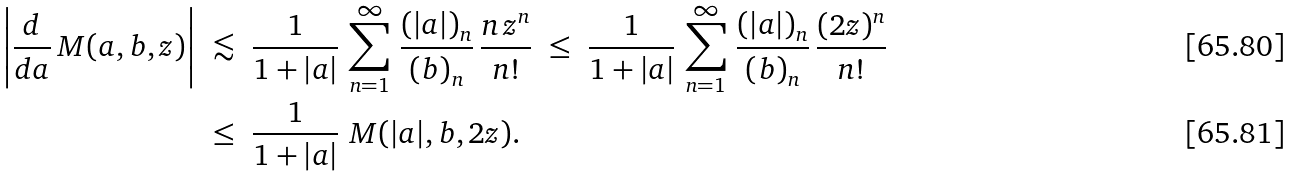Convert formula to latex. <formula><loc_0><loc_0><loc_500><loc_500>\left | \frac { d } { d a } \, M ( a , b , z ) \right | & \ \lesssim \ \frac { 1 } { 1 + | a | } \, \sum _ { n = 1 } ^ { \infty } \, \frac { ( | a | ) _ { n } } { ( b ) _ { n } } \, \frac { n \, z ^ { n } } { n ! } \ \leq \ \frac { 1 } { 1 + | a | } \, \sum _ { n = 1 } ^ { \infty } \, \frac { ( | a | ) _ { n } } { ( b ) _ { n } } \, \frac { ( 2 z ) ^ { n } } { n ! } \\ & \ \leq \ \frac { 1 } { 1 + | a | } \ M ( | a | , b , 2 z ) .</formula> 